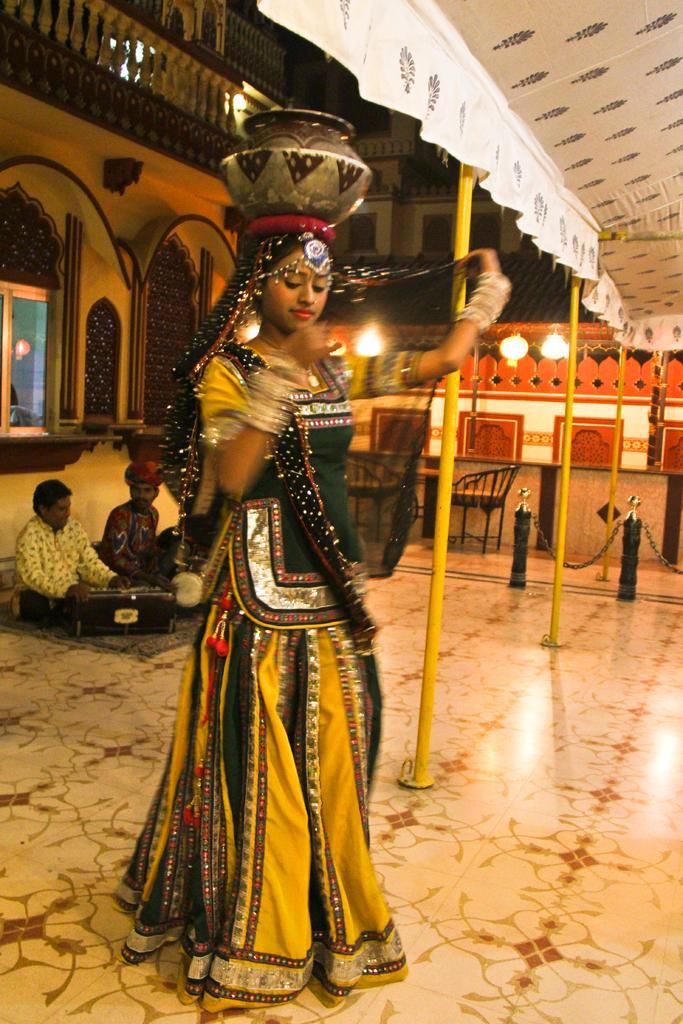Can you describe this image briefly? In the image we can see a woman standing, wearing clothes, dangle, earring, and carrying a pot on her head. This is a pole, floor, light, chair and a musical instrument. There are two men sitting, there is a window and a fence. 